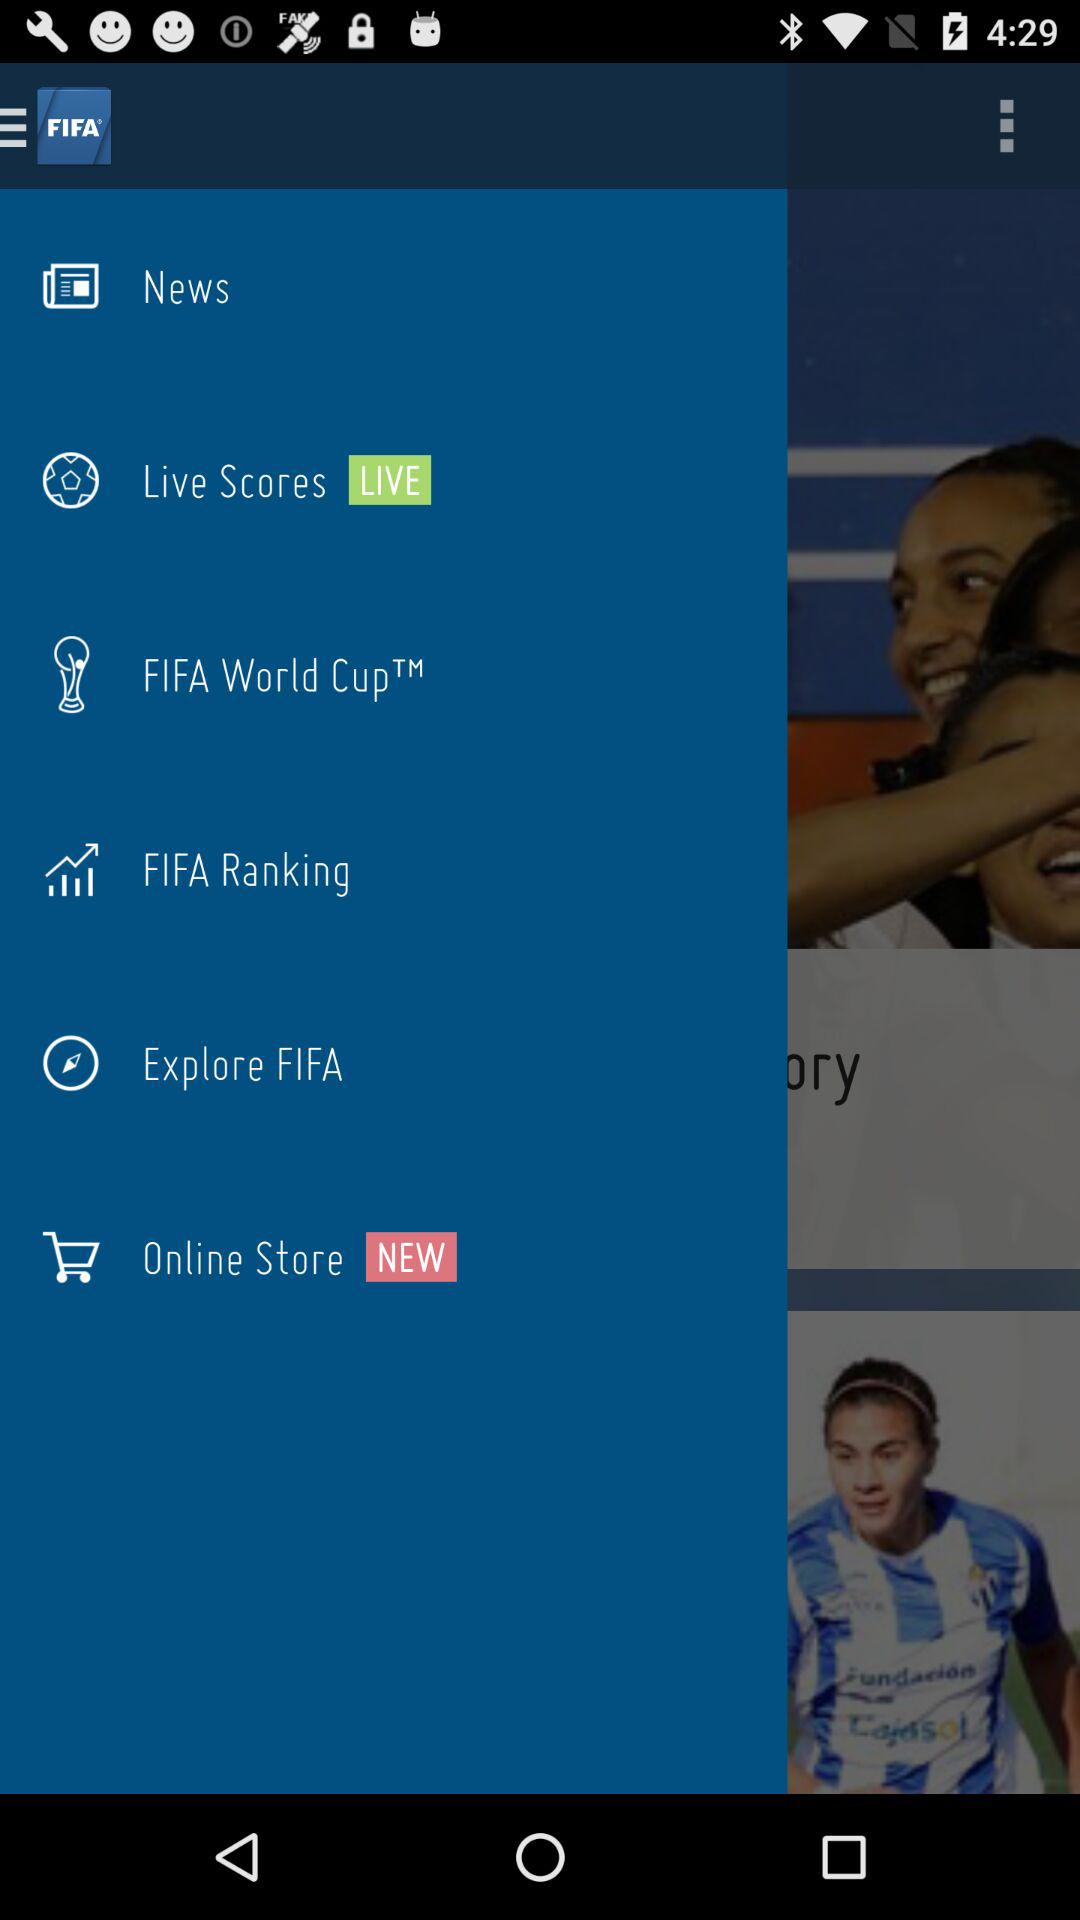What is the application name? The application name is "FIFA". 